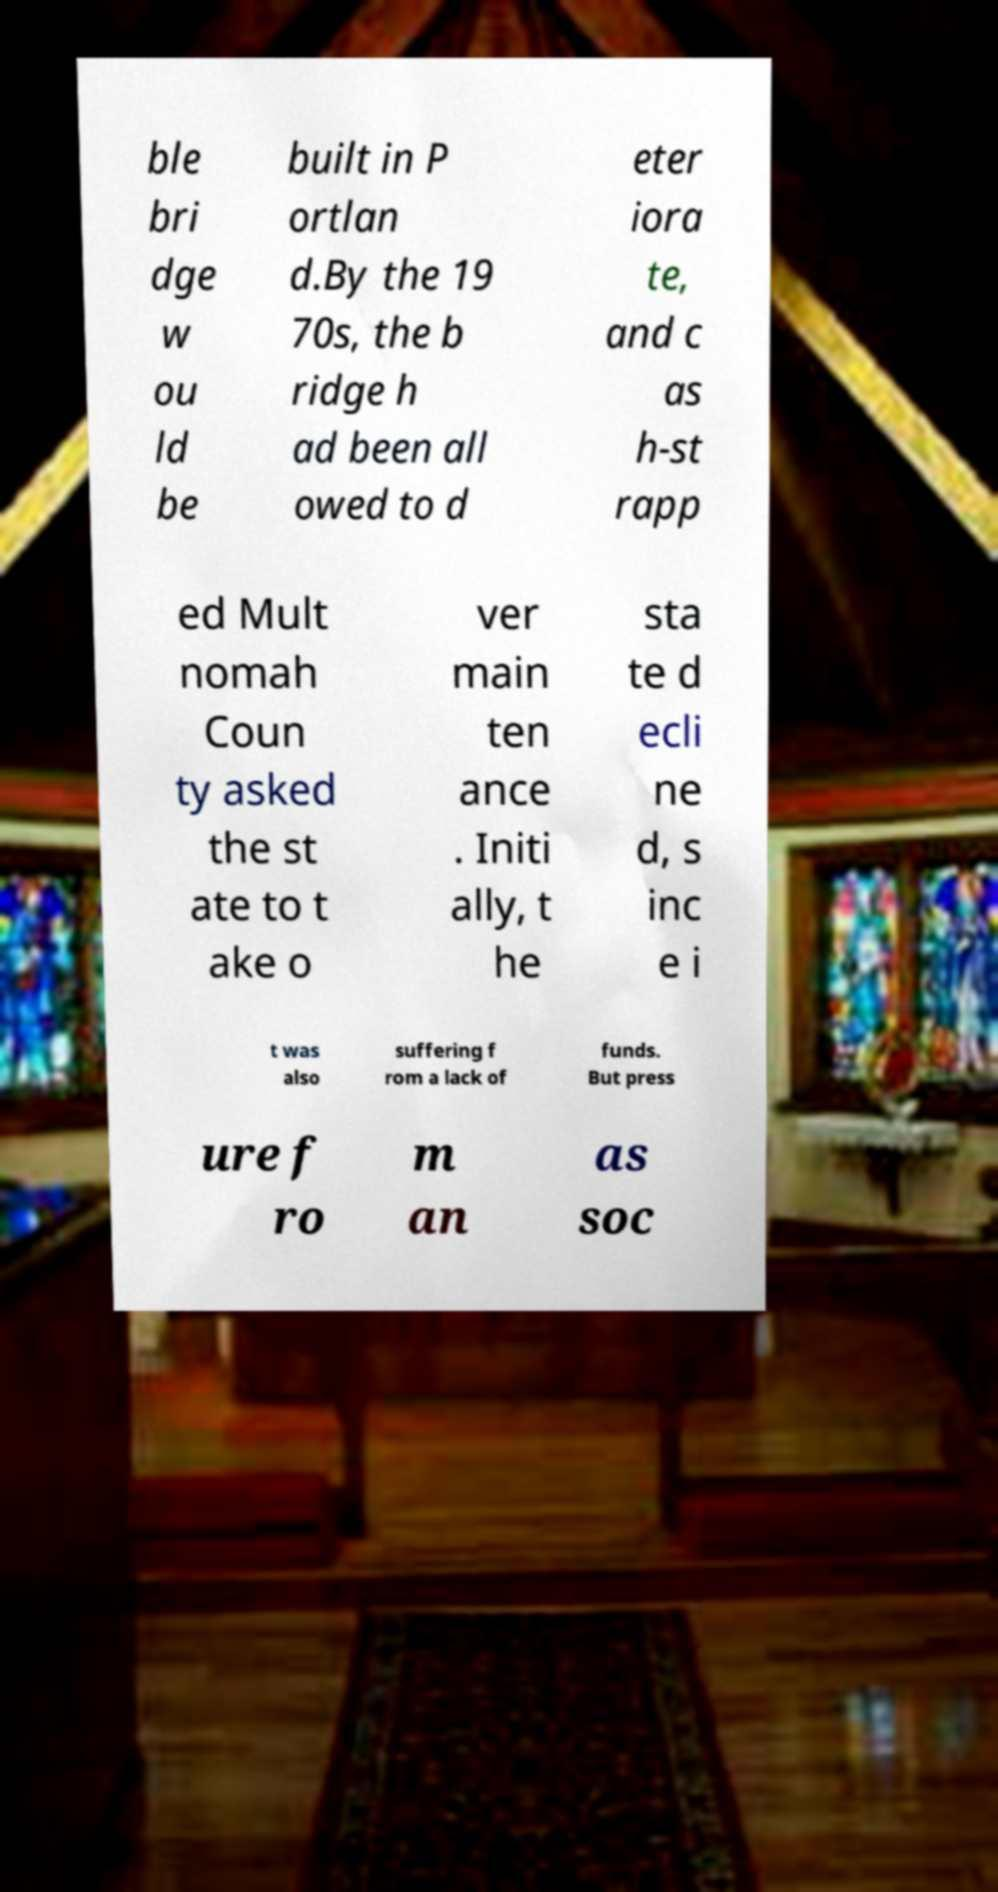Can you accurately transcribe the text from the provided image for me? ble bri dge w ou ld be built in P ortlan d.By the 19 70s, the b ridge h ad been all owed to d eter iora te, and c as h-st rapp ed Mult nomah Coun ty asked the st ate to t ake o ver main ten ance . Initi ally, t he sta te d ecli ne d, s inc e i t was also suffering f rom a lack of funds. But press ure f ro m an as soc 